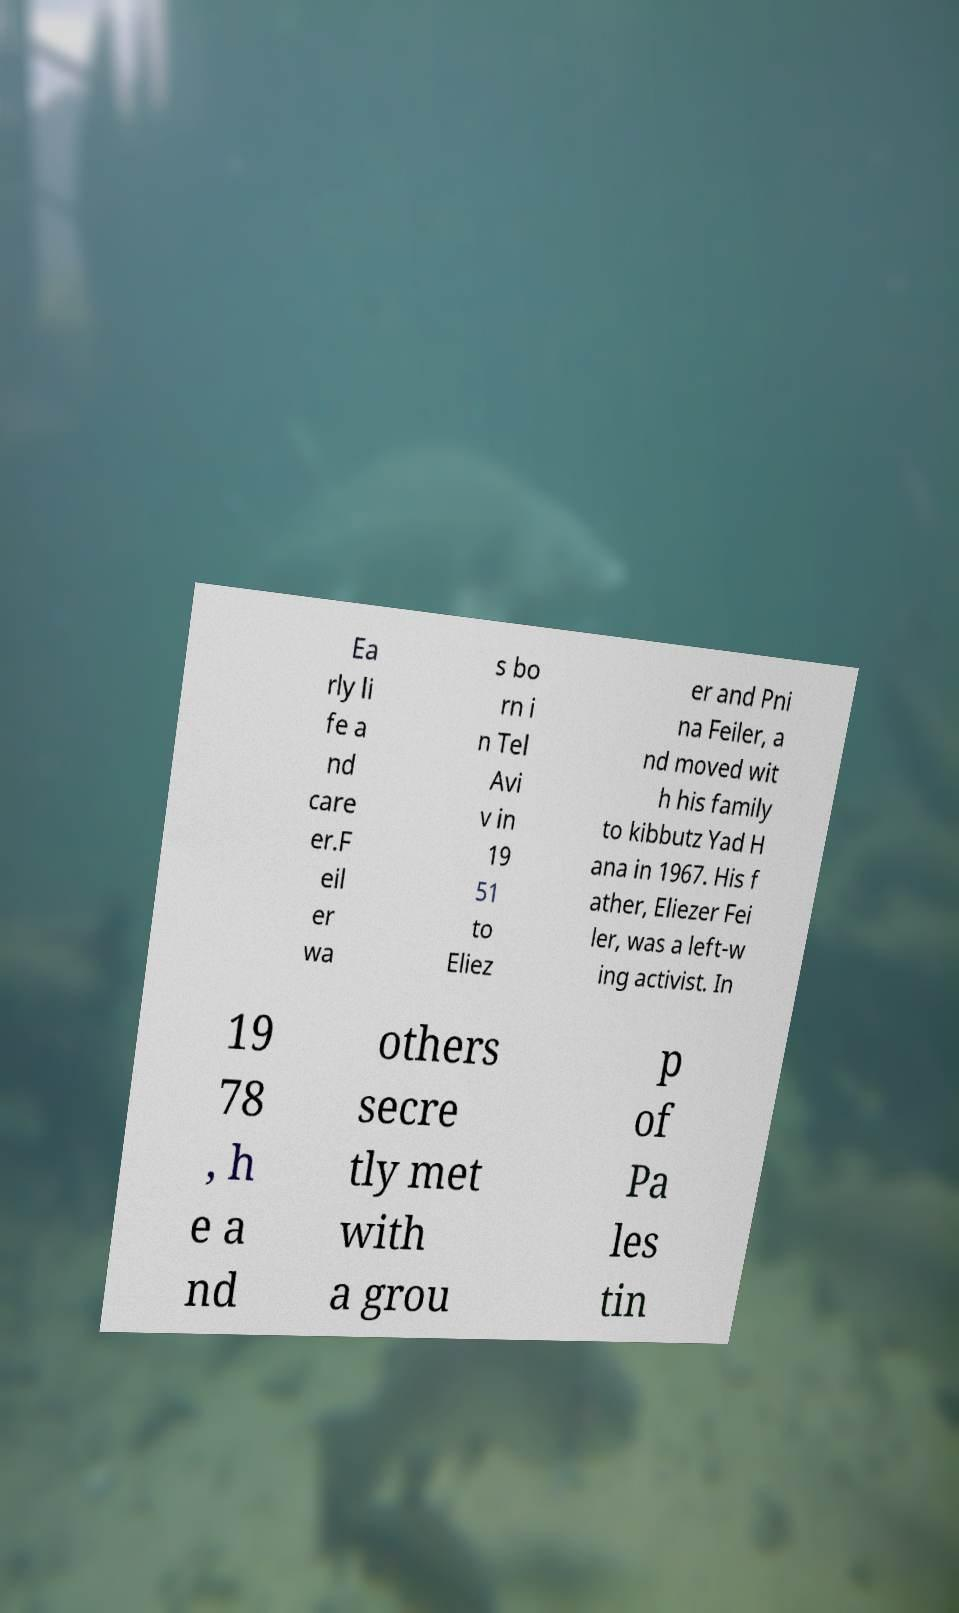Could you extract and type out the text from this image? Ea rly li fe a nd care er.F eil er wa s bo rn i n Tel Avi v in 19 51 to Eliez er and Pni na Feiler, a nd moved wit h his family to kibbutz Yad H ana in 1967. His f ather, Eliezer Fei ler, was a left-w ing activist. In 19 78 , h e a nd others secre tly met with a grou p of Pa les tin 